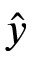<formula> <loc_0><loc_0><loc_500><loc_500>\hat { y }</formula> 